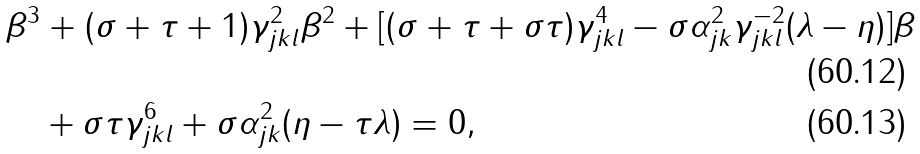Convert formula to latex. <formula><loc_0><loc_0><loc_500><loc_500>& \beta ^ { 3 } + ( \sigma + \tau + 1 ) \gamma _ { j k l } ^ { 2 } \beta ^ { 2 } + [ ( \sigma + \tau + \sigma \tau ) \gamma _ { j k l } ^ { 4 } - \sigma \alpha _ { j k } ^ { 2 } \gamma _ { j k l } ^ { - 2 } ( \lambda - \eta ) ] \beta \\ & \quad + \sigma \tau \gamma _ { j k l } ^ { 6 } + \sigma \alpha _ { j k } ^ { 2 } ( \eta - \tau \lambda ) = 0 ,</formula> 